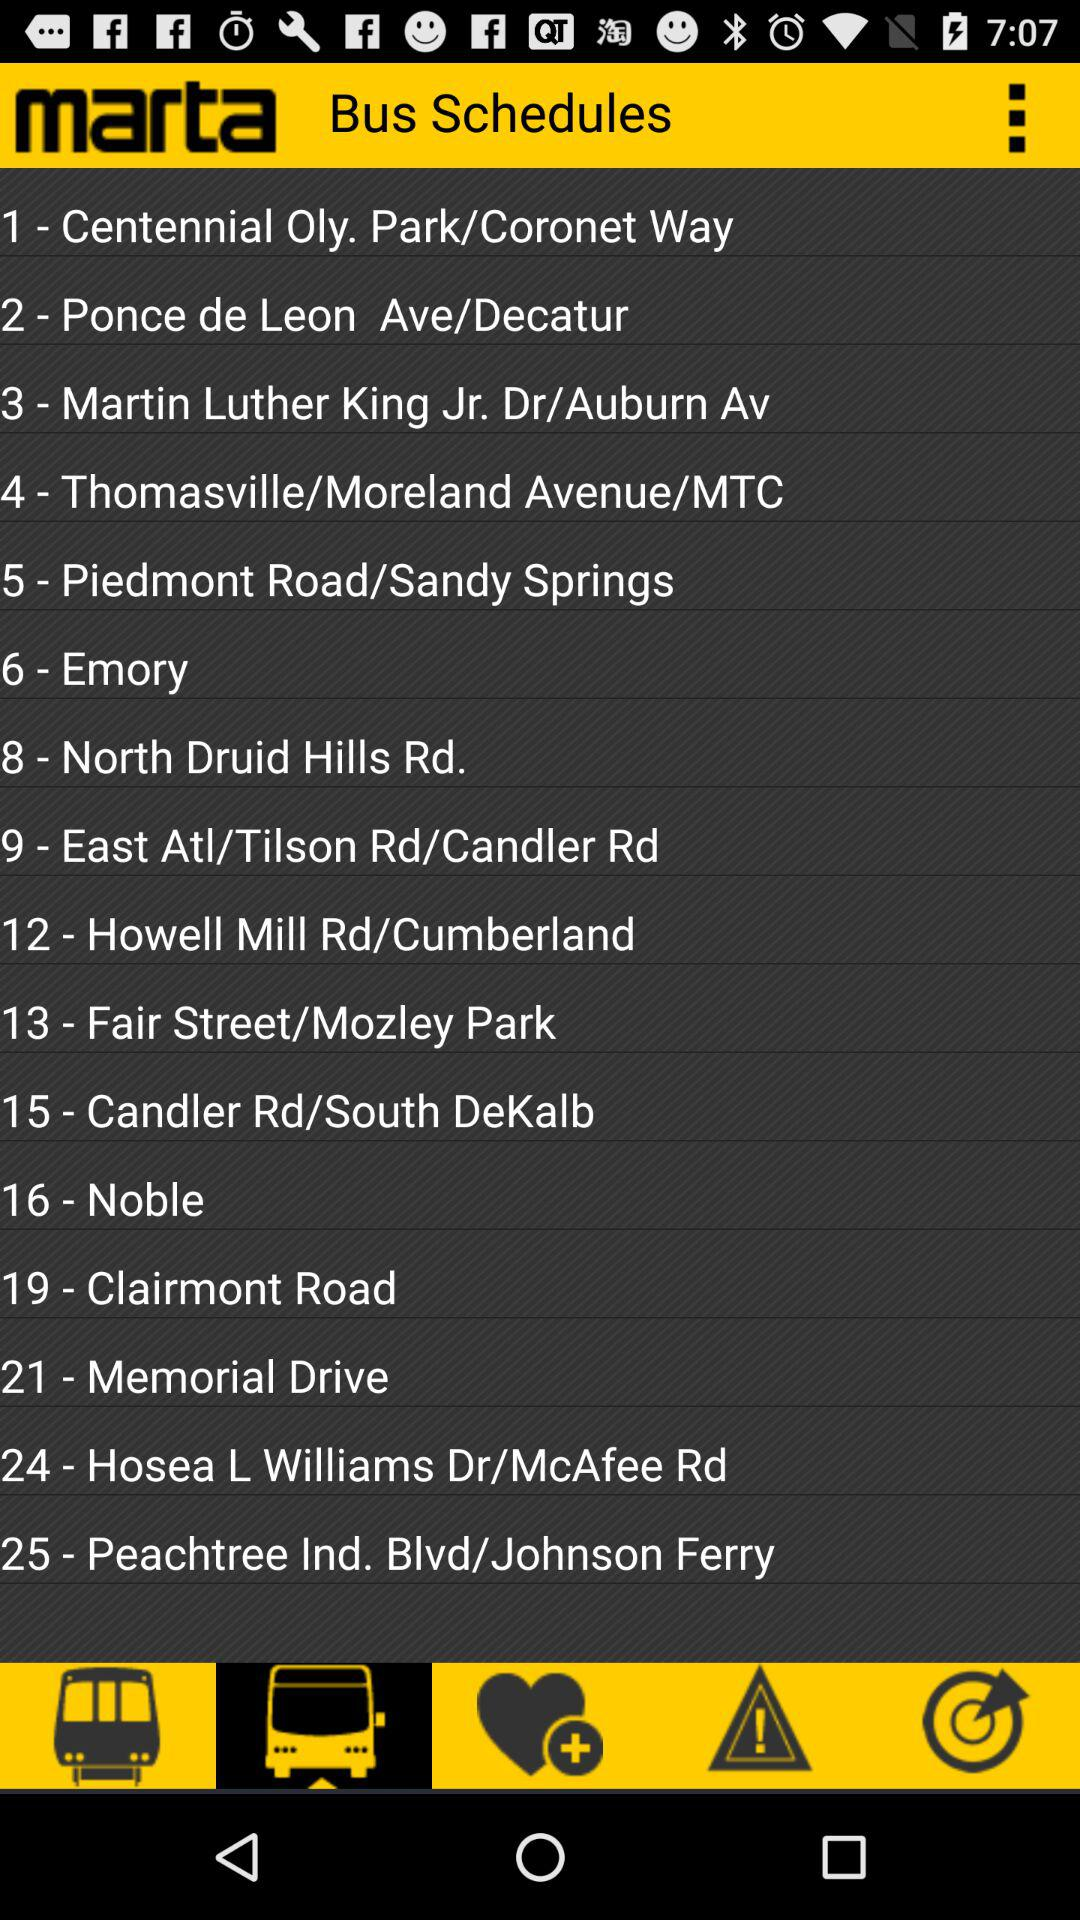What is the application name? The application name is "marta". 